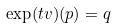Convert formula to latex. <formula><loc_0><loc_0><loc_500><loc_500>\exp ( t v ) ( p ) = q</formula> 